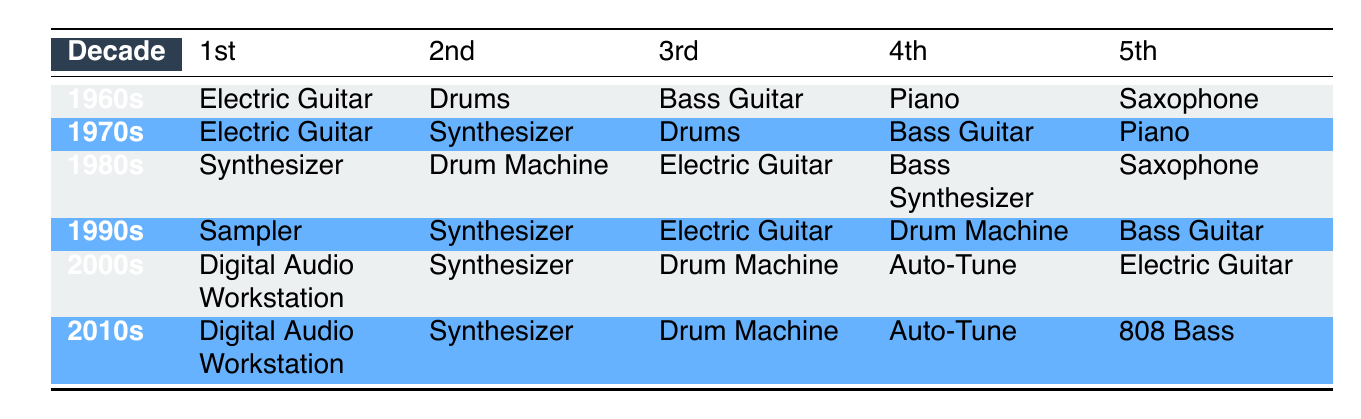What was the most commonly used instrument in the 1980s? The table shows that the 1st most commonly used instrument in the 1980s is the Synthesizer.
Answer: Synthesizer Which decade had the Drums as the 2nd most common instrument? By checking the rows for each decade, we see that Drums was listed as the 2nd most common instrument in both the 1960s and 1970s.
Answer: 1960s, 1970s Is the Electric Guitar found in the top 5 instruments for every decade? Looking at the table, Electric Guitar appears in the top 5 instruments in the 1960s, 1970s, 1980s, and 1990s but is not listed in the top 5 for the 2000s and 2010s. Therefore, the statement is false.
Answer: No What is the trend for the use of Digital Audio Workstations from the 2000s to the 2010s? The table reveals that Digital Audio Workstation is ranked 1st in both the 2000s and 2010s, indicating that its popularity has remained consistent across these two decades.
Answer: Consistent Which instrument appears the most frequently as the 3rd most common instrument from the 1960s to the 2010s? To find this, we check the 3rd instrument across all decades: in the 1960s it's Bass Guitar, in the 1970s it's Drums, in the 1980s it's Electric Guitar, in the 1990s it's Electric Guitar again, in the 2000s it's Drum Machine, and in the 2010s it's Drum Machine. The most frequent one is Electric Guitar appearing twice.
Answer: Electric Guitar In which decades does the Synthesizer appear in the top 3 instruments? By examining the table, Synthesizer appears in the top 3 for the 1970s (2nd), the 1980s (1st), the 1990s (2nd), the 2000s (2nd), and the 2010s (2nd).
Answer: 1970s, 1980s, 1990s, 2000s, 2010s Count the total number of different instruments listed in the 5th position across all decades. Reviewing the table, the instruments listed in the 5th position are: Saxophone (1960s), Piano (1970s), Saxophone (1980s), Bass Guitar (1990s), Electric Guitar (2000s), and 808 Bass (2010s). This gives us 5 distinct instruments: Saxophone, Piano, Bass Guitar, Electric Guitar, and 808 Bass.
Answer: 5 Was there a decade where the Auto-Tune was the 1st most commonly used instrument? Looking at the table, Auto-Tune appears 4th in the 2000s and 4th in the 2010s but is never ranked 1st in any decade. Thus, the answer is no.
Answer: No 